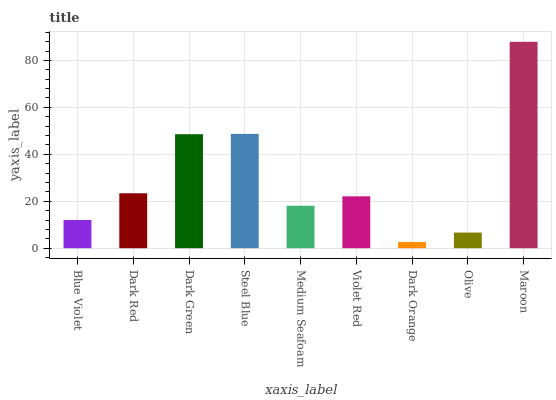Is Dark Orange the minimum?
Answer yes or no. Yes. Is Maroon the maximum?
Answer yes or no. Yes. Is Dark Red the minimum?
Answer yes or no. No. Is Dark Red the maximum?
Answer yes or no. No. Is Dark Red greater than Blue Violet?
Answer yes or no. Yes. Is Blue Violet less than Dark Red?
Answer yes or no. Yes. Is Blue Violet greater than Dark Red?
Answer yes or no. No. Is Dark Red less than Blue Violet?
Answer yes or no. No. Is Violet Red the high median?
Answer yes or no. Yes. Is Violet Red the low median?
Answer yes or no. Yes. Is Dark Green the high median?
Answer yes or no. No. Is Dark Red the low median?
Answer yes or no. No. 